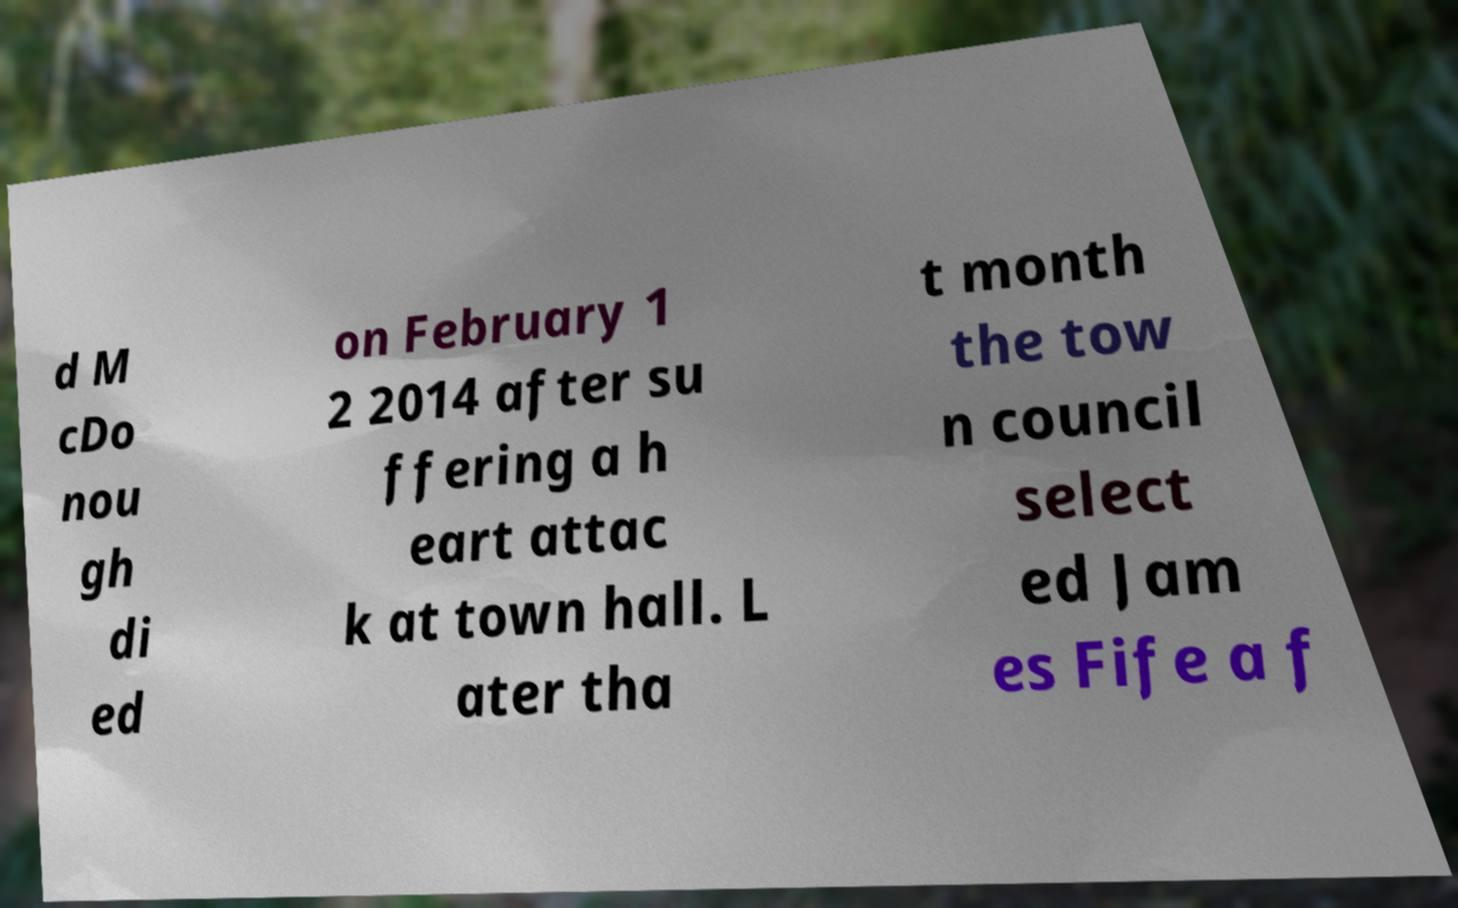There's text embedded in this image that I need extracted. Can you transcribe it verbatim? d M cDo nou gh di ed on February 1 2 2014 after su ffering a h eart attac k at town hall. L ater tha t month the tow n council select ed Jam es Fife a f 